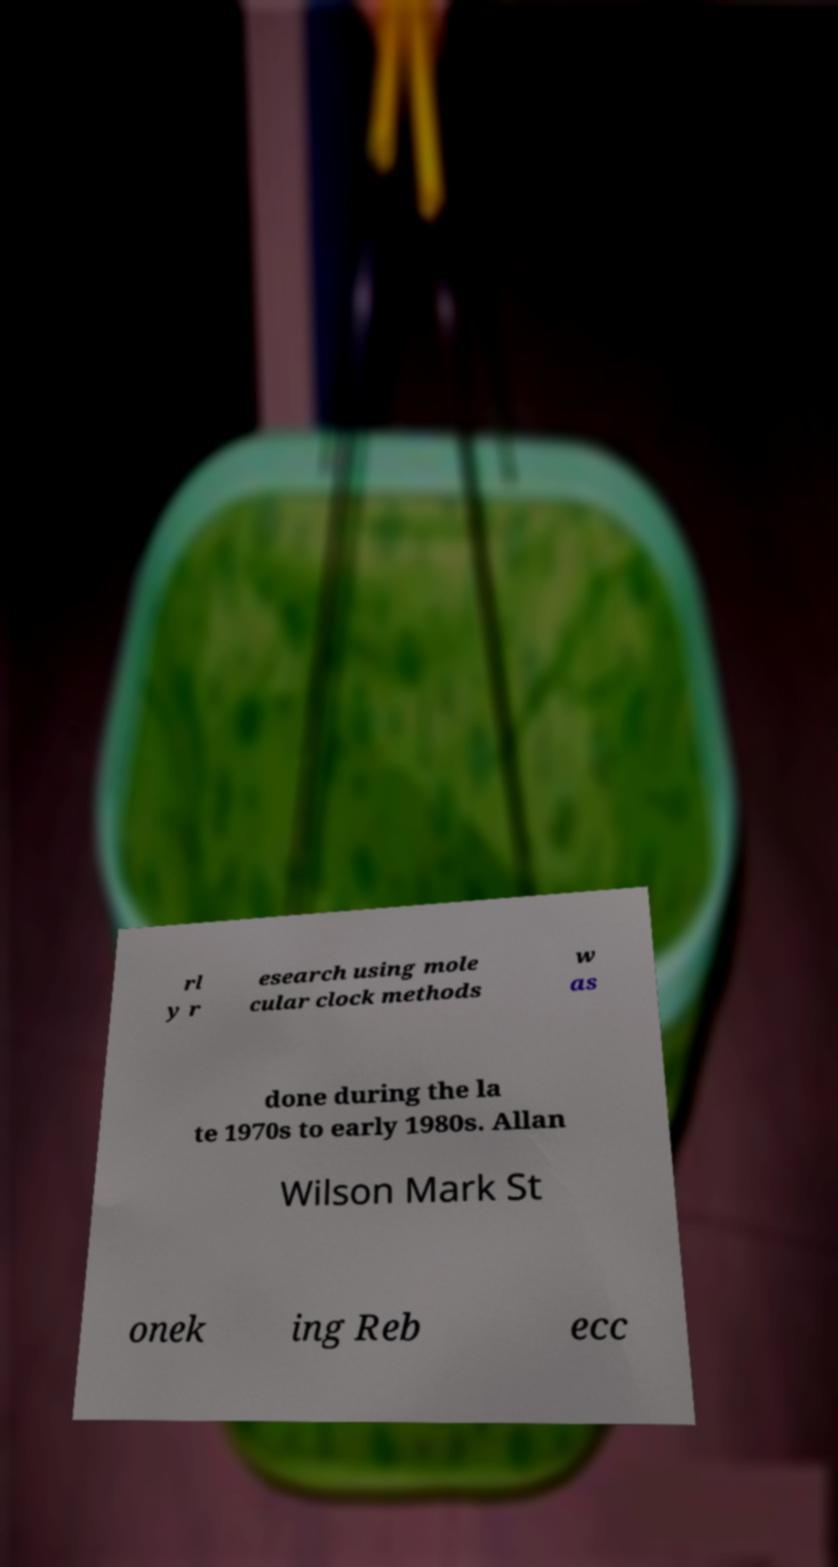Can you accurately transcribe the text from the provided image for me? rl y r esearch using mole cular clock methods w as done during the la te 1970s to early 1980s. Allan Wilson Mark St onek ing Reb ecc 